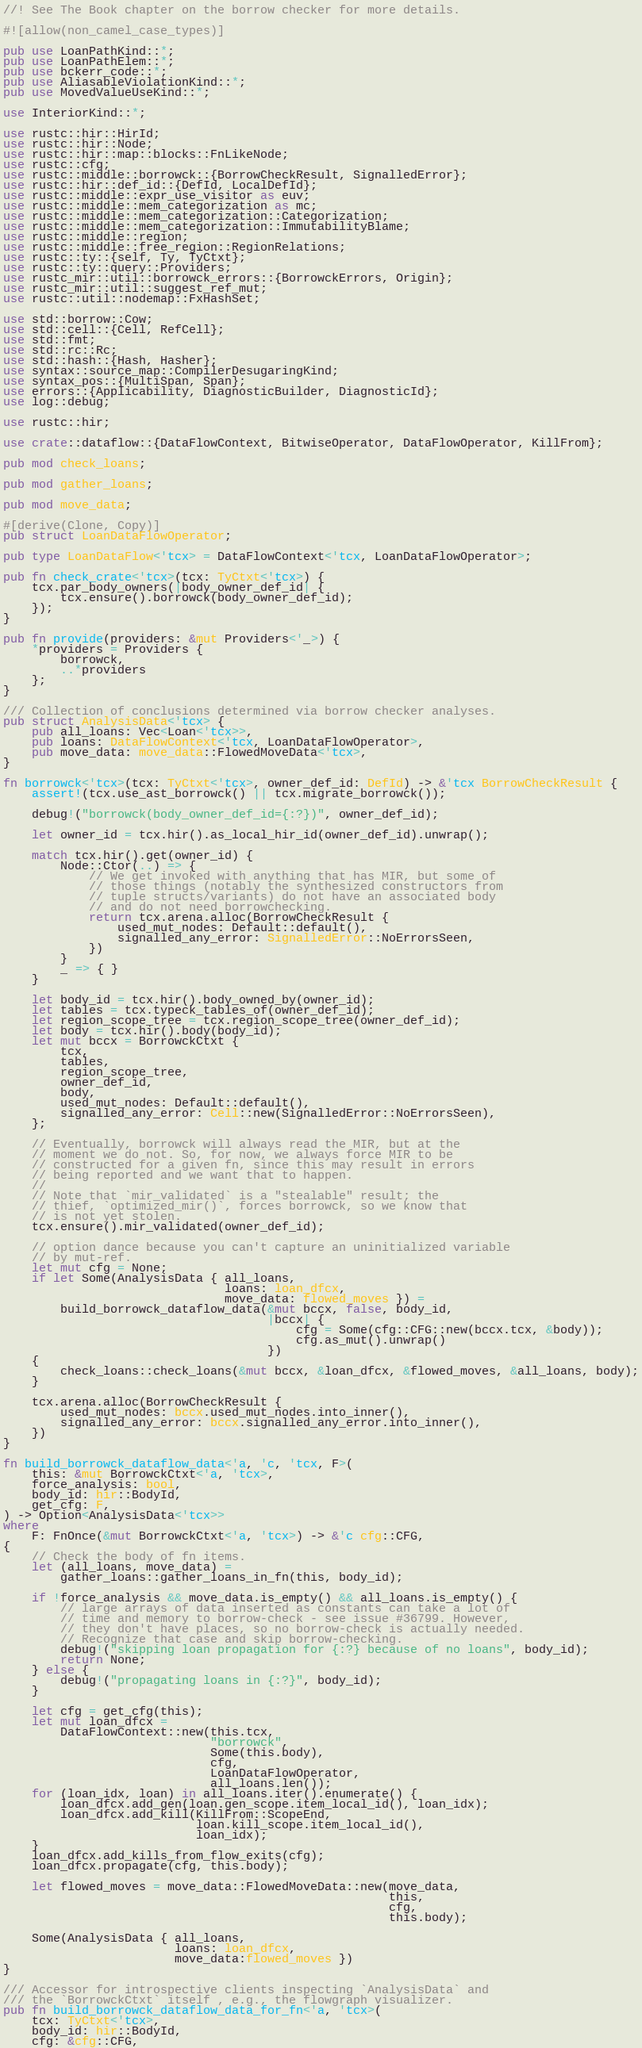<code> <loc_0><loc_0><loc_500><loc_500><_Rust_>//! See The Book chapter on the borrow checker for more details.

#![allow(non_camel_case_types)]

pub use LoanPathKind::*;
pub use LoanPathElem::*;
pub use bckerr_code::*;
pub use AliasableViolationKind::*;
pub use MovedValueUseKind::*;

use InteriorKind::*;

use rustc::hir::HirId;
use rustc::hir::Node;
use rustc::hir::map::blocks::FnLikeNode;
use rustc::cfg;
use rustc::middle::borrowck::{BorrowCheckResult, SignalledError};
use rustc::hir::def_id::{DefId, LocalDefId};
use rustc::middle::expr_use_visitor as euv;
use rustc::middle::mem_categorization as mc;
use rustc::middle::mem_categorization::Categorization;
use rustc::middle::mem_categorization::ImmutabilityBlame;
use rustc::middle::region;
use rustc::middle::free_region::RegionRelations;
use rustc::ty::{self, Ty, TyCtxt};
use rustc::ty::query::Providers;
use rustc_mir::util::borrowck_errors::{BorrowckErrors, Origin};
use rustc_mir::util::suggest_ref_mut;
use rustc::util::nodemap::FxHashSet;

use std::borrow::Cow;
use std::cell::{Cell, RefCell};
use std::fmt;
use std::rc::Rc;
use std::hash::{Hash, Hasher};
use syntax::source_map::CompilerDesugaringKind;
use syntax_pos::{MultiSpan, Span};
use errors::{Applicability, DiagnosticBuilder, DiagnosticId};
use log::debug;

use rustc::hir;

use crate::dataflow::{DataFlowContext, BitwiseOperator, DataFlowOperator, KillFrom};

pub mod check_loans;

pub mod gather_loans;

pub mod move_data;

#[derive(Clone, Copy)]
pub struct LoanDataFlowOperator;

pub type LoanDataFlow<'tcx> = DataFlowContext<'tcx, LoanDataFlowOperator>;

pub fn check_crate<'tcx>(tcx: TyCtxt<'tcx>) {
    tcx.par_body_owners(|body_owner_def_id| {
        tcx.ensure().borrowck(body_owner_def_id);
    });
}

pub fn provide(providers: &mut Providers<'_>) {
    *providers = Providers {
        borrowck,
        ..*providers
    };
}

/// Collection of conclusions determined via borrow checker analyses.
pub struct AnalysisData<'tcx> {
    pub all_loans: Vec<Loan<'tcx>>,
    pub loans: DataFlowContext<'tcx, LoanDataFlowOperator>,
    pub move_data: move_data::FlowedMoveData<'tcx>,
}

fn borrowck<'tcx>(tcx: TyCtxt<'tcx>, owner_def_id: DefId) -> &'tcx BorrowCheckResult {
    assert!(tcx.use_ast_borrowck() || tcx.migrate_borrowck());

    debug!("borrowck(body_owner_def_id={:?})", owner_def_id);

    let owner_id = tcx.hir().as_local_hir_id(owner_def_id).unwrap();

    match tcx.hir().get(owner_id) {
        Node::Ctor(..) => {
            // We get invoked with anything that has MIR, but some of
            // those things (notably the synthesized constructors from
            // tuple structs/variants) do not have an associated body
            // and do not need borrowchecking.
            return tcx.arena.alloc(BorrowCheckResult {
                used_mut_nodes: Default::default(),
                signalled_any_error: SignalledError::NoErrorsSeen,
            })
        }
        _ => { }
    }

    let body_id = tcx.hir().body_owned_by(owner_id);
    let tables = tcx.typeck_tables_of(owner_def_id);
    let region_scope_tree = tcx.region_scope_tree(owner_def_id);
    let body = tcx.hir().body(body_id);
    let mut bccx = BorrowckCtxt {
        tcx,
        tables,
        region_scope_tree,
        owner_def_id,
        body,
        used_mut_nodes: Default::default(),
        signalled_any_error: Cell::new(SignalledError::NoErrorsSeen),
    };

    // Eventually, borrowck will always read the MIR, but at the
    // moment we do not. So, for now, we always force MIR to be
    // constructed for a given fn, since this may result in errors
    // being reported and we want that to happen.
    //
    // Note that `mir_validated` is a "stealable" result; the
    // thief, `optimized_mir()`, forces borrowck, so we know that
    // is not yet stolen.
    tcx.ensure().mir_validated(owner_def_id);

    // option dance because you can't capture an uninitialized variable
    // by mut-ref.
    let mut cfg = None;
    if let Some(AnalysisData { all_loans,
                               loans: loan_dfcx,
                               move_data: flowed_moves }) =
        build_borrowck_dataflow_data(&mut bccx, false, body_id,
                                     |bccx| {
                                         cfg = Some(cfg::CFG::new(bccx.tcx, &body));
                                         cfg.as_mut().unwrap()
                                     })
    {
        check_loans::check_loans(&mut bccx, &loan_dfcx, &flowed_moves, &all_loans, body);
    }

    tcx.arena.alloc(BorrowCheckResult {
        used_mut_nodes: bccx.used_mut_nodes.into_inner(),
        signalled_any_error: bccx.signalled_any_error.into_inner(),
    })
}

fn build_borrowck_dataflow_data<'a, 'c, 'tcx, F>(
    this: &mut BorrowckCtxt<'a, 'tcx>,
    force_analysis: bool,
    body_id: hir::BodyId,
    get_cfg: F,
) -> Option<AnalysisData<'tcx>>
where
    F: FnOnce(&mut BorrowckCtxt<'a, 'tcx>) -> &'c cfg::CFG,
{
    // Check the body of fn items.
    let (all_loans, move_data) =
        gather_loans::gather_loans_in_fn(this, body_id);

    if !force_analysis && move_data.is_empty() && all_loans.is_empty() {
        // large arrays of data inserted as constants can take a lot of
        // time and memory to borrow-check - see issue #36799. However,
        // they don't have places, so no borrow-check is actually needed.
        // Recognize that case and skip borrow-checking.
        debug!("skipping loan propagation for {:?} because of no loans", body_id);
        return None;
    } else {
        debug!("propagating loans in {:?}", body_id);
    }

    let cfg = get_cfg(this);
    let mut loan_dfcx =
        DataFlowContext::new(this.tcx,
                             "borrowck",
                             Some(this.body),
                             cfg,
                             LoanDataFlowOperator,
                             all_loans.len());
    for (loan_idx, loan) in all_loans.iter().enumerate() {
        loan_dfcx.add_gen(loan.gen_scope.item_local_id(), loan_idx);
        loan_dfcx.add_kill(KillFrom::ScopeEnd,
                           loan.kill_scope.item_local_id(),
                           loan_idx);
    }
    loan_dfcx.add_kills_from_flow_exits(cfg);
    loan_dfcx.propagate(cfg, this.body);

    let flowed_moves = move_data::FlowedMoveData::new(move_data,
                                                      this,
                                                      cfg,
                                                      this.body);

    Some(AnalysisData { all_loans,
                        loans: loan_dfcx,
                        move_data:flowed_moves })
}

/// Accessor for introspective clients inspecting `AnalysisData` and
/// the `BorrowckCtxt` itself , e.g., the flowgraph visualizer.
pub fn build_borrowck_dataflow_data_for_fn<'a, 'tcx>(
    tcx: TyCtxt<'tcx>,
    body_id: hir::BodyId,
    cfg: &cfg::CFG,</code> 